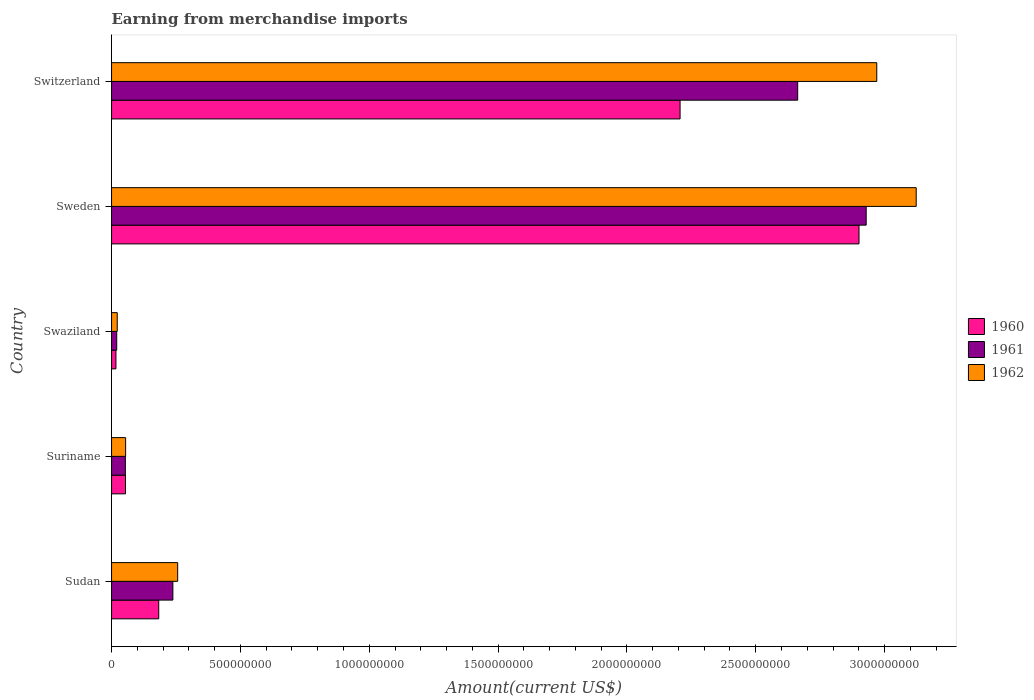How many different coloured bars are there?
Your answer should be compact. 3. Are the number of bars per tick equal to the number of legend labels?
Offer a terse response. Yes. What is the label of the 1st group of bars from the top?
Keep it short and to the point. Switzerland. What is the amount earned from merchandise imports in 1962 in Sudan?
Your response must be concise. 2.57e+08. Across all countries, what is the maximum amount earned from merchandise imports in 1960?
Give a very brief answer. 2.90e+09. Across all countries, what is the minimum amount earned from merchandise imports in 1962?
Provide a short and direct response. 2.20e+07. In which country was the amount earned from merchandise imports in 1960 maximum?
Provide a short and direct response. Sweden. In which country was the amount earned from merchandise imports in 1962 minimum?
Offer a terse response. Swaziland. What is the total amount earned from merchandise imports in 1962 in the graph?
Offer a terse response. 6.43e+09. What is the difference between the amount earned from merchandise imports in 1962 in Suriname and that in Sweden?
Your answer should be compact. -3.07e+09. What is the difference between the amount earned from merchandise imports in 1961 in Sudan and the amount earned from merchandise imports in 1962 in Swaziland?
Make the answer very short. 2.16e+08. What is the average amount earned from merchandise imports in 1960 per country?
Give a very brief answer. 1.07e+09. What is the difference between the amount earned from merchandise imports in 1961 and amount earned from merchandise imports in 1962 in Switzerland?
Offer a terse response. -3.07e+08. In how many countries, is the amount earned from merchandise imports in 1962 greater than 2400000000 US$?
Provide a succinct answer. 2. What is the ratio of the amount earned from merchandise imports in 1962 in Suriname to that in Sweden?
Your response must be concise. 0.02. Is the amount earned from merchandise imports in 1961 in Sudan less than that in Swaziland?
Keep it short and to the point. No. Is the difference between the amount earned from merchandise imports in 1961 in Suriname and Switzerland greater than the difference between the amount earned from merchandise imports in 1962 in Suriname and Switzerland?
Give a very brief answer. Yes. What is the difference between the highest and the second highest amount earned from merchandise imports in 1960?
Your answer should be very brief. 6.94e+08. What is the difference between the highest and the lowest amount earned from merchandise imports in 1961?
Your response must be concise. 2.91e+09. Is it the case that in every country, the sum of the amount earned from merchandise imports in 1960 and amount earned from merchandise imports in 1961 is greater than the amount earned from merchandise imports in 1962?
Your response must be concise. Yes. How many bars are there?
Provide a succinct answer. 15. Are all the bars in the graph horizontal?
Offer a very short reply. Yes. How many countries are there in the graph?
Offer a terse response. 5. Are the values on the major ticks of X-axis written in scientific E-notation?
Provide a succinct answer. No. Does the graph contain any zero values?
Offer a very short reply. No. How many legend labels are there?
Provide a short and direct response. 3. What is the title of the graph?
Ensure brevity in your answer.  Earning from merchandise imports. What is the label or title of the X-axis?
Offer a very short reply. Amount(current US$). What is the Amount(current US$) of 1960 in Sudan?
Your answer should be compact. 1.83e+08. What is the Amount(current US$) in 1961 in Sudan?
Offer a very short reply. 2.38e+08. What is the Amount(current US$) of 1962 in Sudan?
Make the answer very short. 2.57e+08. What is the Amount(current US$) of 1960 in Suriname?
Your answer should be compact. 5.41e+07. What is the Amount(current US$) in 1961 in Suriname?
Your answer should be very brief. 5.36e+07. What is the Amount(current US$) of 1962 in Suriname?
Offer a very short reply. 5.46e+07. What is the Amount(current US$) of 1960 in Swaziland?
Provide a succinct answer. 1.70e+07. What is the Amount(current US$) of 1962 in Swaziland?
Provide a short and direct response. 2.20e+07. What is the Amount(current US$) in 1960 in Sweden?
Offer a very short reply. 2.90e+09. What is the Amount(current US$) in 1961 in Sweden?
Offer a terse response. 2.93e+09. What is the Amount(current US$) in 1962 in Sweden?
Your answer should be very brief. 3.12e+09. What is the Amount(current US$) of 1960 in Switzerland?
Offer a very short reply. 2.21e+09. What is the Amount(current US$) of 1961 in Switzerland?
Offer a terse response. 2.66e+09. What is the Amount(current US$) of 1962 in Switzerland?
Give a very brief answer. 2.97e+09. Across all countries, what is the maximum Amount(current US$) in 1960?
Give a very brief answer. 2.90e+09. Across all countries, what is the maximum Amount(current US$) in 1961?
Make the answer very short. 2.93e+09. Across all countries, what is the maximum Amount(current US$) of 1962?
Your answer should be compact. 3.12e+09. Across all countries, what is the minimum Amount(current US$) in 1960?
Your answer should be very brief. 1.70e+07. Across all countries, what is the minimum Amount(current US$) of 1961?
Provide a succinct answer. 2.00e+07. Across all countries, what is the minimum Amount(current US$) in 1962?
Provide a short and direct response. 2.20e+07. What is the total Amount(current US$) of 1960 in the graph?
Give a very brief answer. 5.36e+09. What is the total Amount(current US$) in 1961 in the graph?
Your answer should be compact. 5.90e+09. What is the total Amount(current US$) in 1962 in the graph?
Your answer should be very brief. 6.43e+09. What is the difference between the Amount(current US$) in 1960 in Sudan and that in Suriname?
Provide a short and direct response. 1.29e+08. What is the difference between the Amount(current US$) in 1961 in Sudan and that in Suriname?
Your answer should be compact. 1.84e+08. What is the difference between the Amount(current US$) in 1962 in Sudan and that in Suriname?
Ensure brevity in your answer.  2.02e+08. What is the difference between the Amount(current US$) of 1960 in Sudan and that in Swaziland?
Your answer should be very brief. 1.66e+08. What is the difference between the Amount(current US$) of 1961 in Sudan and that in Swaziland?
Provide a short and direct response. 2.18e+08. What is the difference between the Amount(current US$) in 1962 in Sudan and that in Swaziland?
Offer a very short reply. 2.35e+08. What is the difference between the Amount(current US$) of 1960 in Sudan and that in Sweden?
Your answer should be compact. -2.72e+09. What is the difference between the Amount(current US$) of 1961 in Sudan and that in Sweden?
Keep it short and to the point. -2.69e+09. What is the difference between the Amount(current US$) in 1962 in Sudan and that in Sweden?
Make the answer very short. -2.87e+09. What is the difference between the Amount(current US$) in 1960 in Sudan and that in Switzerland?
Your answer should be very brief. -2.02e+09. What is the difference between the Amount(current US$) of 1961 in Sudan and that in Switzerland?
Provide a short and direct response. -2.42e+09. What is the difference between the Amount(current US$) of 1962 in Sudan and that in Switzerland?
Your answer should be compact. -2.71e+09. What is the difference between the Amount(current US$) of 1960 in Suriname and that in Swaziland?
Ensure brevity in your answer.  3.71e+07. What is the difference between the Amount(current US$) in 1961 in Suriname and that in Swaziland?
Provide a short and direct response. 3.36e+07. What is the difference between the Amount(current US$) in 1962 in Suriname and that in Swaziland?
Make the answer very short. 3.26e+07. What is the difference between the Amount(current US$) in 1960 in Suriname and that in Sweden?
Your answer should be compact. -2.85e+09. What is the difference between the Amount(current US$) in 1961 in Suriname and that in Sweden?
Your answer should be very brief. -2.87e+09. What is the difference between the Amount(current US$) of 1962 in Suriname and that in Sweden?
Provide a succinct answer. -3.07e+09. What is the difference between the Amount(current US$) of 1960 in Suriname and that in Switzerland?
Provide a short and direct response. -2.15e+09. What is the difference between the Amount(current US$) of 1961 in Suriname and that in Switzerland?
Keep it short and to the point. -2.61e+09. What is the difference between the Amount(current US$) in 1962 in Suriname and that in Switzerland?
Keep it short and to the point. -2.92e+09. What is the difference between the Amount(current US$) of 1960 in Swaziland and that in Sweden?
Provide a short and direct response. -2.88e+09. What is the difference between the Amount(current US$) of 1961 in Swaziland and that in Sweden?
Ensure brevity in your answer.  -2.91e+09. What is the difference between the Amount(current US$) of 1962 in Swaziland and that in Sweden?
Offer a terse response. -3.10e+09. What is the difference between the Amount(current US$) of 1960 in Swaziland and that in Switzerland?
Your answer should be very brief. -2.19e+09. What is the difference between the Amount(current US$) of 1961 in Swaziland and that in Switzerland?
Your answer should be very brief. -2.64e+09. What is the difference between the Amount(current US$) in 1962 in Swaziland and that in Switzerland?
Offer a terse response. -2.95e+09. What is the difference between the Amount(current US$) in 1960 in Sweden and that in Switzerland?
Provide a succinct answer. 6.94e+08. What is the difference between the Amount(current US$) in 1961 in Sweden and that in Switzerland?
Offer a terse response. 2.66e+08. What is the difference between the Amount(current US$) in 1962 in Sweden and that in Switzerland?
Your response must be concise. 1.53e+08. What is the difference between the Amount(current US$) of 1960 in Sudan and the Amount(current US$) of 1961 in Suriname?
Your answer should be compact. 1.29e+08. What is the difference between the Amount(current US$) of 1960 in Sudan and the Amount(current US$) of 1962 in Suriname?
Offer a very short reply. 1.28e+08. What is the difference between the Amount(current US$) in 1961 in Sudan and the Amount(current US$) in 1962 in Suriname?
Provide a succinct answer. 1.83e+08. What is the difference between the Amount(current US$) in 1960 in Sudan and the Amount(current US$) in 1961 in Swaziland?
Ensure brevity in your answer.  1.63e+08. What is the difference between the Amount(current US$) in 1960 in Sudan and the Amount(current US$) in 1962 in Swaziland?
Ensure brevity in your answer.  1.61e+08. What is the difference between the Amount(current US$) of 1961 in Sudan and the Amount(current US$) of 1962 in Swaziland?
Give a very brief answer. 2.16e+08. What is the difference between the Amount(current US$) in 1960 in Sudan and the Amount(current US$) in 1961 in Sweden?
Keep it short and to the point. -2.75e+09. What is the difference between the Amount(current US$) in 1960 in Sudan and the Amount(current US$) in 1962 in Sweden?
Your answer should be very brief. -2.94e+09. What is the difference between the Amount(current US$) in 1961 in Sudan and the Amount(current US$) in 1962 in Sweden?
Offer a very short reply. -2.88e+09. What is the difference between the Amount(current US$) of 1960 in Sudan and the Amount(current US$) of 1961 in Switzerland?
Your answer should be very brief. -2.48e+09. What is the difference between the Amount(current US$) in 1960 in Sudan and the Amount(current US$) in 1962 in Switzerland?
Provide a succinct answer. -2.79e+09. What is the difference between the Amount(current US$) of 1961 in Sudan and the Amount(current US$) of 1962 in Switzerland?
Offer a very short reply. -2.73e+09. What is the difference between the Amount(current US$) of 1960 in Suriname and the Amount(current US$) of 1961 in Swaziland?
Keep it short and to the point. 3.41e+07. What is the difference between the Amount(current US$) of 1960 in Suriname and the Amount(current US$) of 1962 in Swaziland?
Make the answer very short. 3.21e+07. What is the difference between the Amount(current US$) of 1961 in Suriname and the Amount(current US$) of 1962 in Swaziland?
Offer a very short reply. 3.16e+07. What is the difference between the Amount(current US$) of 1960 in Suriname and the Amount(current US$) of 1961 in Sweden?
Offer a very short reply. -2.87e+09. What is the difference between the Amount(current US$) of 1960 in Suriname and the Amount(current US$) of 1962 in Sweden?
Offer a very short reply. -3.07e+09. What is the difference between the Amount(current US$) in 1961 in Suriname and the Amount(current US$) in 1962 in Sweden?
Offer a terse response. -3.07e+09. What is the difference between the Amount(current US$) in 1960 in Suriname and the Amount(current US$) in 1961 in Switzerland?
Offer a terse response. -2.61e+09. What is the difference between the Amount(current US$) in 1960 in Suriname and the Amount(current US$) in 1962 in Switzerland?
Your answer should be very brief. -2.92e+09. What is the difference between the Amount(current US$) of 1961 in Suriname and the Amount(current US$) of 1962 in Switzerland?
Offer a terse response. -2.92e+09. What is the difference between the Amount(current US$) in 1960 in Swaziland and the Amount(current US$) in 1961 in Sweden?
Offer a very short reply. -2.91e+09. What is the difference between the Amount(current US$) in 1960 in Swaziland and the Amount(current US$) in 1962 in Sweden?
Provide a succinct answer. -3.11e+09. What is the difference between the Amount(current US$) of 1961 in Swaziland and the Amount(current US$) of 1962 in Sweden?
Offer a terse response. -3.10e+09. What is the difference between the Amount(current US$) in 1960 in Swaziland and the Amount(current US$) in 1961 in Switzerland?
Make the answer very short. -2.65e+09. What is the difference between the Amount(current US$) of 1960 in Swaziland and the Amount(current US$) of 1962 in Switzerland?
Make the answer very short. -2.95e+09. What is the difference between the Amount(current US$) of 1961 in Swaziland and the Amount(current US$) of 1962 in Switzerland?
Provide a short and direct response. -2.95e+09. What is the difference between the Amount(current US$) in 1960 in Sweden and the Amount(current US$) in 1961 in Switzerland?
Make the answer very short. 2.38e+08. What is the difference between the Amount(current US$) of 1960 in Sweden and the Amount(current US$) of 1962 in Switzerland?
Offer a terse response. -6.89e+07. What is the difference between the Amount(current US$) in 1961 in Sweden and the Amount(current US$) in 1962 in Switzerland?
Keep it short and to the point. -4.11e+07. What is the average Amount(current US$) in 1960 per country?
Keep it short and to the point. 1.07e+09. What is the average Amount(current US$) in 1961 per country?
Provide a succinct answer. 1.18e+09. What is the average Amount(current US$) in 1962 per country?
Your answer should be very brief. 1.29e+09. What is the difference between the Amount(current US$) of 1960 and Amount(current US$) of 1961 in Sudan?
Provide a short and direct response. -5.49e+07. What is the difference between the Amount(current US$) in 1960 and Amount(current US$) in 1962 in Sudan?
Provide a short and direct response. -7.35e+07. What is the difference between the Amount(current US$) of 1961 and Amount(current US$) of 1962 in Sudan?
Ensure brevity in your answer.  -1.86e+07. What is the difference between the Amount(current US$) of 1960 and Amount(current US$) of 1961 in Suriname?
Ensure brevity in your answer.  4.56e+05. What is the difference between the Amount(current US$) in 1960 and Amount(current US$) in 1962 in Suriname?
Ensure brevity in your answer.  -5.52e+05. What is the difference between the Amount(current US$) of 1961 and Amount(current US$) of 1962 in Suriname?
Keep it short and to the point. -1.01e+06. What is the difference between the Amount(current US$) in 1960 and Amount(current US$) in 1961 in Swaziland?
Keep it short and to the point. -3.00e+06. What is the difference between the Amount(current US$) of 1960 and Amount(current US$) of 1962 in Swaziland?
Your answer should be very brief. -5.00e+06. What is the difference between the Amount(current US$) in 1961 and Amount(current US$) in 1962 in Swaziland?
Keep it short and to the point. -2.00e+06. What is the difference between the Amount(current US$) in 1960 and Amount(current US$) in 1961 in Sweden?
Your response must be concise. -2.78e+07. What is the difference between the Amount(current US$) in 1960 and Amount(current US$) in 1962 in Sweden?
Offer a very short reply. -2.22e+08. What is the difference between the Amount(current US$) in 1961 and Amount(current US$) in 1962 in Sweden?
Offer a very short reply. -1.94e+08. What is the difference between the Amount(current US$) in 1960 and Amount(current US$) in 1961 in Switzerland?
Keep it short and to the point. -4.56e+08. What is the difference between the Amount(current US$) of 1960 and Amount(current US$) of 1962 in Switzerland?
Ensure brevity in your answer.  -7.63e+08. What is the difference between the Amount(current US$) of 1961 and Amount(current US$) of 1962 in Switzerland?
Make the answer very short. -3.07e+08. What is the ratio of the Amount(current US$) in 1960 in Sudan to that in Suriname?
Keep it short and to the point. 3.39. What is the ratio of the Amount(current US$) in 1961 in Sudan to that in Suriname?
Provide a short and direct response. 4.44. What is the ratio of the Amount(current US$) in 1962 in Sudan to that in Suriname?
Make the answer very short. 4.7. What is the ratio of the Amount(current US$) in 1960 in Sudan to that in Swaziland?
Your answer should be very brief. 10.77. What is the ratio of the Amount(current US$) in 1961 in Sudan to that in Swaziland?
Keep it short and to the point. 11.9. What is the ratio of the Amount(current US$) of 1962 in Sudan to that in Swaziland?
Your response must be concise. 11.66. What is the ratio of the Amount(current US$) in 1960 in Sudan to that in Sweden?
Provide a short and direct response. 0.06. What is the ratio of the Amount(current US$) of 1961 in Sudan to that in Sweden?
Offer a very short reply. 0.08. What is the ratio of the Amount(current US$) in 1962 in Sudan to that in Sweden?
Provide a succinct answer. 0.08. What is the ratio of the Amount(current US$) in 1960 in Sudan to that in Switzerland?
Give a very brief answer. 0.08. What is the ratio of the Amount(current US$) of 1961 in Sudan to that in Switzerland?
Offer a terse response. 0.09. What is the ratio of the Amount(current US$) in 1962 in Sudan to that in Switzerland?
Make the answer very short. 0.09. What is the ratio of the Amount(current US$) in 1960 in Suriname to that in Swaziland?
Offer a very short reply. 3.18. What is the ratio of the Amount(current US$) of 1961 in Suriname to that in Swaziland?
Ensure brevity in your answer.  2.68. What is the ratio of the Amount(current US$) of 1962 in Suriname to that in Swaziland?
Make the answer very short. 2.48. What is the ratio of the Amount(current US$) of 1960 in Suriname to that in Sweden?
Your answer should be compact. 0.02. What is the ratio of the Amount(current US$) in 1961 in Suriname to that in Sweden?
Provide a short and direct response. 0.02. What is the ratio of the Amount(current US$) in 1962 in Suriname to that in Sweden?
Keep it short and to the point. 0.02. What is the ratio of the Amount(current US$) in 1960 in Suriname to that in Switzerland?
Make the answer very short. 0.02. What is the ratio of the Amount(current US$) in 1961 in Suriname to that in Switzerland?
Offer a very short reply. 0.02. What is the ratio of the Amount(current US$) in 1962 in Suriname to that in Switzerland?
Your response must be concise. 0.02. What is the ratio of the Amount(current US$) of 1960 in Swaziland to that in Sweden?
Make the answer very short. 0.01. What is the ratio of the Amount(current US$) in 1961 in Swaziland to that in Sweden?
Offer a very short reply. 0.01. What is the ratio of the Amount(current US$) in 1962 in Swaziland to that in Sweden?
Your answer should be compact. 0.01. What is the ratio of the Amount(current US$) in 1960 in Swaziland to that in Switzerland?
Provide a succinct answer. 0.01. What is the ratio of the Amount(current US$) of 1961 in Swaziland to that in Switzerland?
Your answer should be compact. 0.01. What is the ratio of the Amount(current US$) of 1962 in Swaziland to that in Switzerland?
Offer a terse response. 0.01. What is the ratio of the Amount(current US$) in 1960 in Sweden to that in Switzerland?
Your answer should be very brief. 1.31. What is the ratio of the Amount(current US$) of 1961 in Sweden to that in Switzerland?
Keep it short and to the point. 1.1. What is the ratio of the Amount(current US$) of 1962 in Sweden to that in Switzerland?
Offer a terse response. 1.05. What is the difference between the highest and the second highest Amount(current US$) of 1960?
Your response must be concise. 6.94e+08. What is the difference between the highest and the second highest Amount(current US$) in 1961?
Offer a terse response. 2.66e+08. What is the difference between the highest and the second highest Amount(current US$) of 1962?
Provide a short and direct response. 1.53e+08. What is the difference between the highest and the lowest Amount(current US$) in 1960?
Keep it short and to the point. 2.88e+09. What is the difference between the highest and the lowest Amount(current US$) of 1961?
Make the answer very short. 2.91e+09. What is the difference between the highest and the lowest Amount(current US$) of 1962?
Your answer should be very brief. 3.10e+09. 